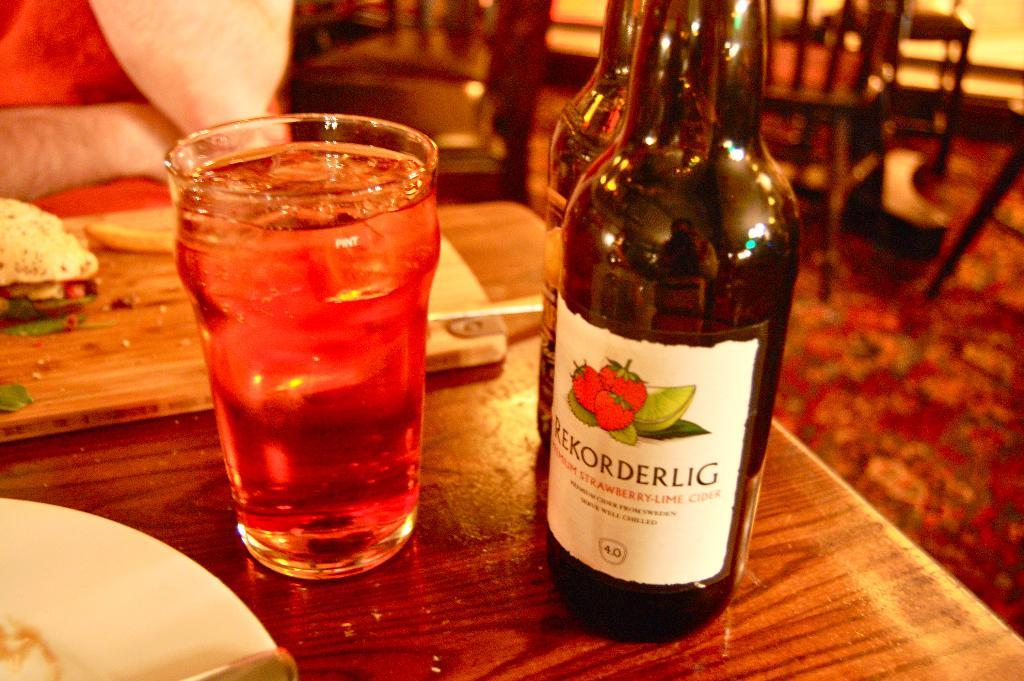<image>
Share a concise interpretation of the image provided. A bottle of Rekorderlig sits on a table next to a filled glass 